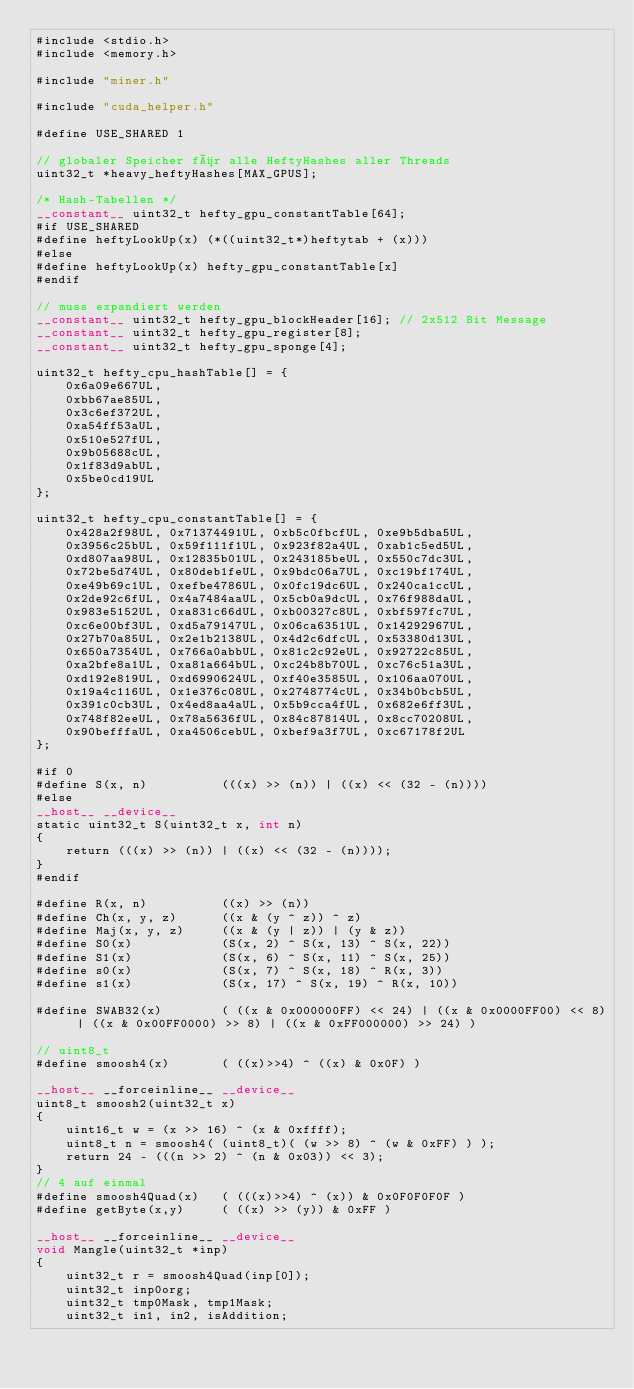<code> <loc_0><loc_0><loc_500><loc_500><_Cuda_>#include <stdio.h>
#include <memory.h>

#include "miner.h"

#include "cuda_helper.h"

#define USE_SHARED 1

// globaler Speicher für alle HeftyHashes aller Threads
uint32_t *heavy_heftyHashes[MAX_GPUS];

/* Hash-Tabellen */
__constant__ uint32_t hefty_gpu_constantTable[64];
#if USE_SHARED
#define heftyLookUp(x) (*((uint32_t*)heftytab + (x)))
#else
#define heftyLookUp(x) hefty_gpu_constantTable[x]
#endif

// muss expandiert werden
__constant__ uint32_t hefty_gpu_blockHeader[16]; // 2x512 Bit Message
__constant__ uint32_t hefty_gpu_register[8];
__constant__ uint32_t hefty_gpu_sponge[4];

uint32_t hefty_cpu_hashTable[] = {
    0x6a09e667UL,
    0xbb67ae85UL,
    0x3c6ef372UL,
    0xa54ff53aUL,
    0x510e527fUL,
    0x9b05688cUL,
    0x1f83d9abUL,
    0x5be0cd19UL
};

uint32_t hefty_cpu_constantTable[] = {
    0x428a2f98UL, 0x71374491UL, 0xb5c0fbcfUL, 0xe9b5dba5UL,
    0x3956c25bUL, 0x59f111f1UL, 0x923f82a4UL, 0xab1c5ed5UL,
    0xd807aa98UL, 0x12835b01UL, 0x243185beUL, 0x550c7dc3UL,
    0x72be5d74UL, 0x80deb1feUL, 0x9bdc06a7UL, 0xc19bf174UL,
    0xe49b69c1UL, 0xefbe4786UL, 0x0fc19dc6UL, 0x240ca1ccUL,
    0x2de92c6fUL, 0x4a7484aaUL, 0x5cb0a9dcUL, 0x76f988daUL,
    0x983e5152UL, 0xa831c66dUL, 0xb00327c8UL, 0xbf597fc7UL,
    0xc6e00bf3UL, 0xd5a79147UL, 0x06ca6351UL, 0x14292967UL,
    0x27b70a85UL, 0x2e1b2138UL, 0x4d2c6dfcUL, 0x53380d13UL,
    0x650a7354UL, 0x766a0abbUL, 0x81c2c92eUL, 0x92722c85UL,
    0xa2bfe8a1UL, 0xa81a664bUL, 0xc24b8b70UL, 0xc76c51a3UL,
    0xd192e819UL, 0xd6990624UL, 0xf40e3585UL, 0x106aa070UL,
    0x19a4c116UL, 0x1e376c08UL, 0x2748774cUL, 0x34b0bcb5UL,
    0x391c0cb3UL, 0x4ed8aa4aUL, 0x5b9cca4fUL, 0x682e6ff3UL,
    0x748f82eeUL, 0x78a5636fUL, 0x84c87814UL, 0x8cc70208UL,
    0x90befffaUL, 0xa4506cebUL, 0xbef9a3f7UL, 0xc67178f2UL
};

#if 0
#define S(x, n)          (((x) >> (n)) | ((x) << (32 - (n))))
#else
__host__ __device__
static uint32_t S(uint32_t x, int n)
{
    return (((x) >> (n)) | ((x) << (32 - (n))));
}
#endif

#define R(x, n)          ((x) >> (n))
#define Ch(x, y, z)      ((x & (y ^ z)) ^ z)
#define Maj(x, y, z)     ((x & (y | z)) | (y & z))
#define S0(x)            (S(x, 2) ^ S(x, 13) ^ S(x, 22))
#define S1(x)            (S(x, 6) ^ S(x, 11) ^ S(x, 25))
#define s0(x)            (S(x, 7) ^ S(x, 18) ^ R(x, 3))
#define s1(x)            (S(x, 17) ^ S(x, 19) ^ R(x, 10))

#define SWAB32(x)        ( ((x & 0x000000FF) << 24) | ((x & 0x0000FF00) << 8) | ((x & 0x00FF0000) >> 8) | ((x & 0xFF000000) >> 24) )

// uint8_t
#define smoosh4(x)       ( ((x)>>4) ^ ((x) & 0x0F) )

__host__ __forceinline__ __device__
uint8_t smoosh2(uint32_t x)
{
    uint16_t w = (x >> 16) ^ (x & 0xffff);
    uint8_t n = smoosh4( (uint8_t)( (w >> 8) ^ (w & 0xFF) ) );
    return 24 - (((n >> 2) ^ (n & 0x03)) << 3);
}
// 4 auf einmal
#define smoosh4Quad(x)   ( (((x)>>4) ^ (x)) & 0x0F0F0F0F )
#define getByte(x,y)     ( ((x) >> (y)) & 0xFF )

__host__ __forceinline__ __device__
void Mangle(uint32_t *inp)
{
    uint32_t r = smoosh4Quad(inp[0]);
    uint32_t inp0org;
    uint32_t tmp0Mask, tmp1Mask;
    uint32_t in1, in2, isAddition;</code> 